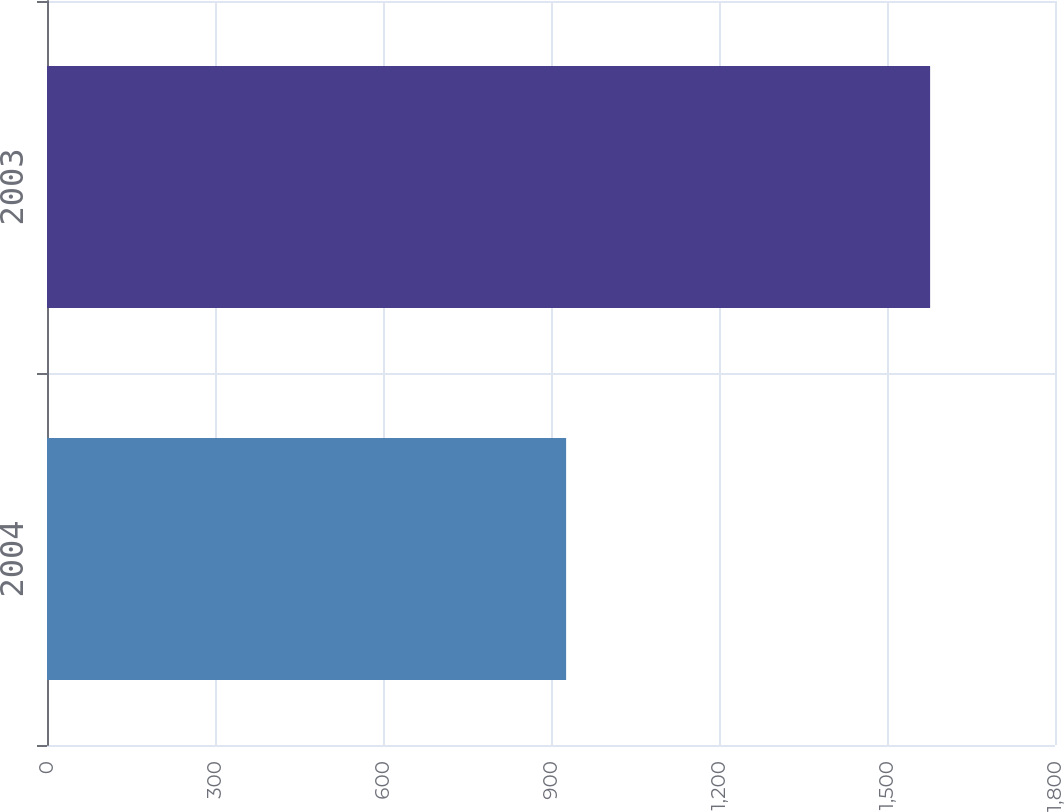Convert chart. <chart><loc_0><loc_0><loc_500><loc_500><bar_chart><fcel>2004<fcel>2003<nl><fcel>927<fcel>1577<nl></chart> 